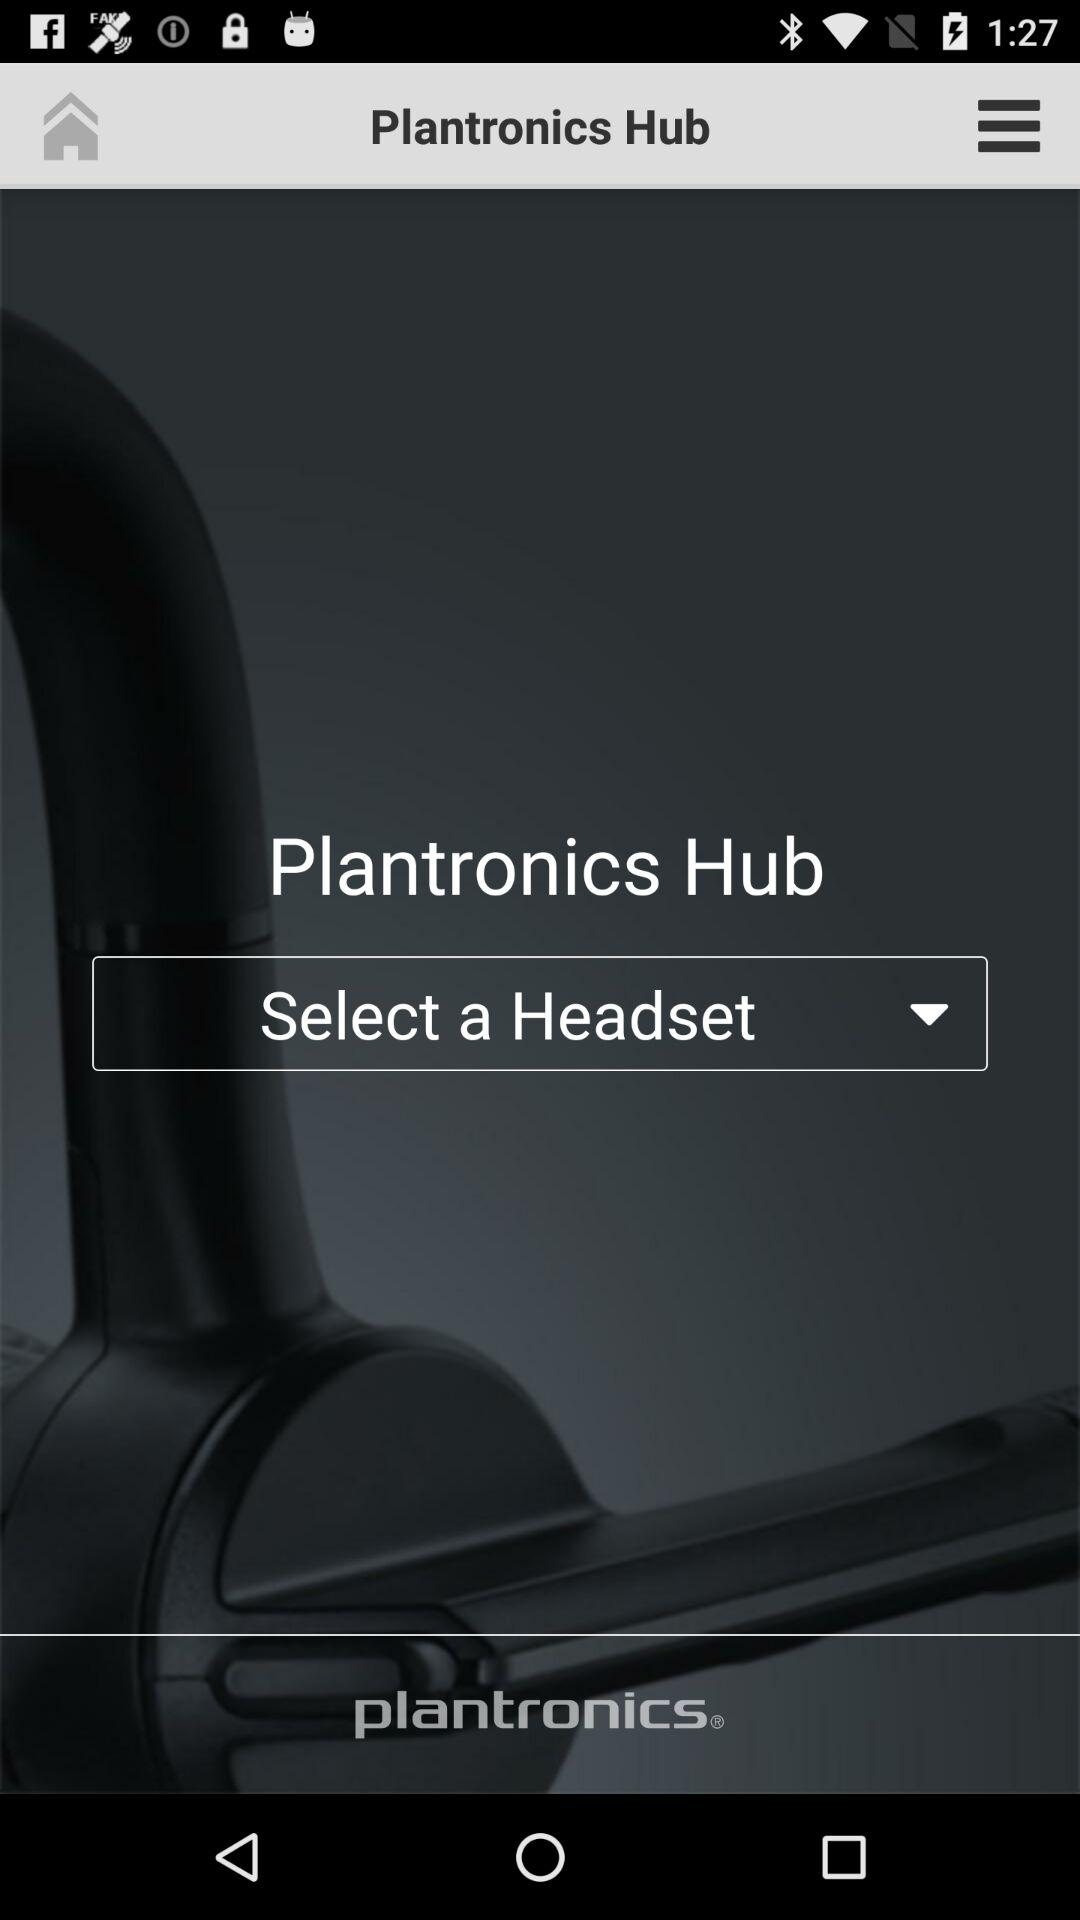What is the application name? The application name is "Plantronics Hub". 